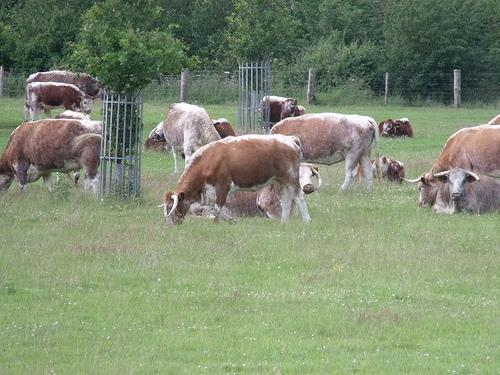Question: how many animals are there?
Choices:
A. 26.
B. 86.
C. 12.
D. 14.
Answer with the letter. Answer: D Question: why are the animals in the field?
Choices:
A. Sleeping.
B. Running.
C. They are grazing.
D. Herding.
Answer with the letter. Answer: C Question: where are the animals?
Choices:
A. Zoo.
B. In a grazing field.
C. Park.
D. Forest.
Answer with the letter. Answer: B Question: what are the animals doing?
Choices:
A. Swimming.
B. Eating.
C. Running.
D. Grazing.
Answer with the letter. Answer: D Question: how many fence posts are visible?
Choices:
A. 2.
B. 9.
C. 4.
D. 5.
Answer with the letter. Answer: D 